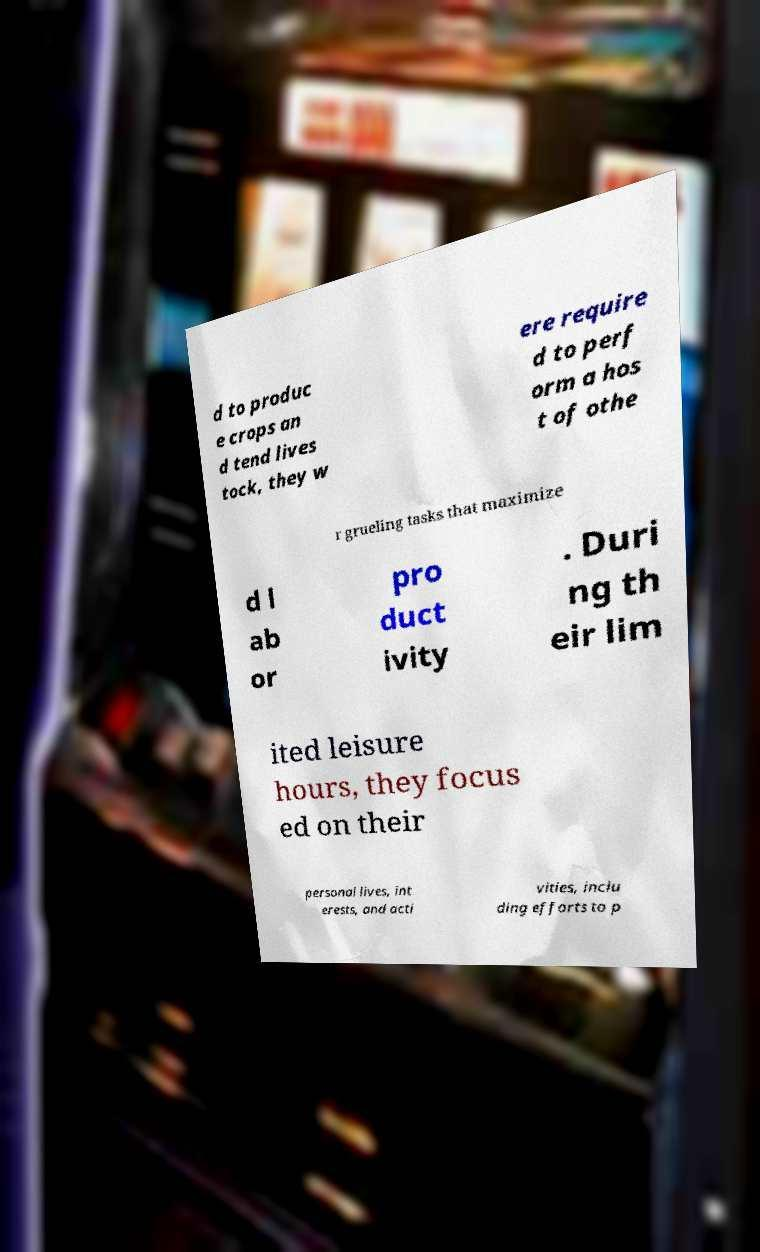Could you assist in decoding the text presented in this image and type it out clearly? d to produc e crops an d tend lives tock, they w ere require d to perf orm a hos t of othe r grueling tasks that maximize d l ab or pro duct ivity . Duri ng th eir lim ited leisure hours, they focus ed on their personal lives, int erests, and acti vities, inclu ding efforts to p 